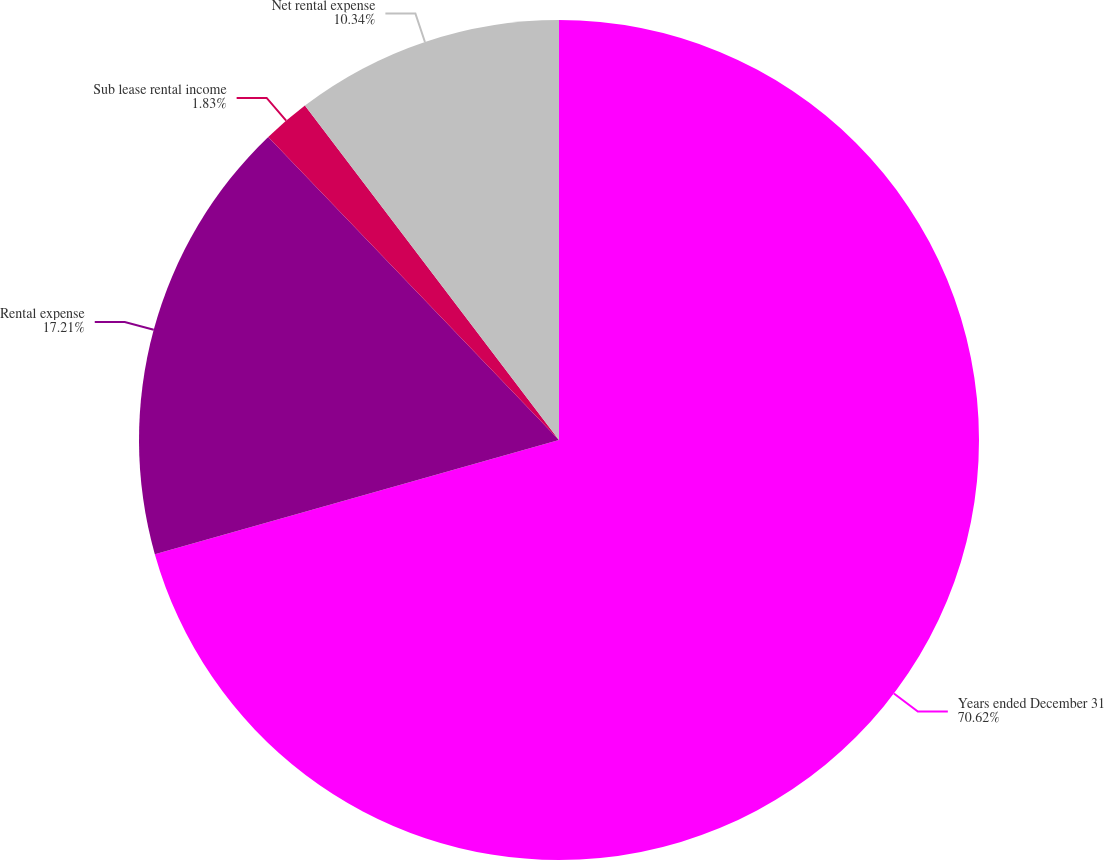<chart> <loc_0><loc_0><loc_500><loc_500><pie_chart><fcel>Years ended December 31<fcel>Rental expense<fcel>Sub lease rental income<fcel>Net rental expense<nl><fcel>70.62%<fcel>17.21%<fcel>1.83%<fcel>10.34%<nl></chart> 